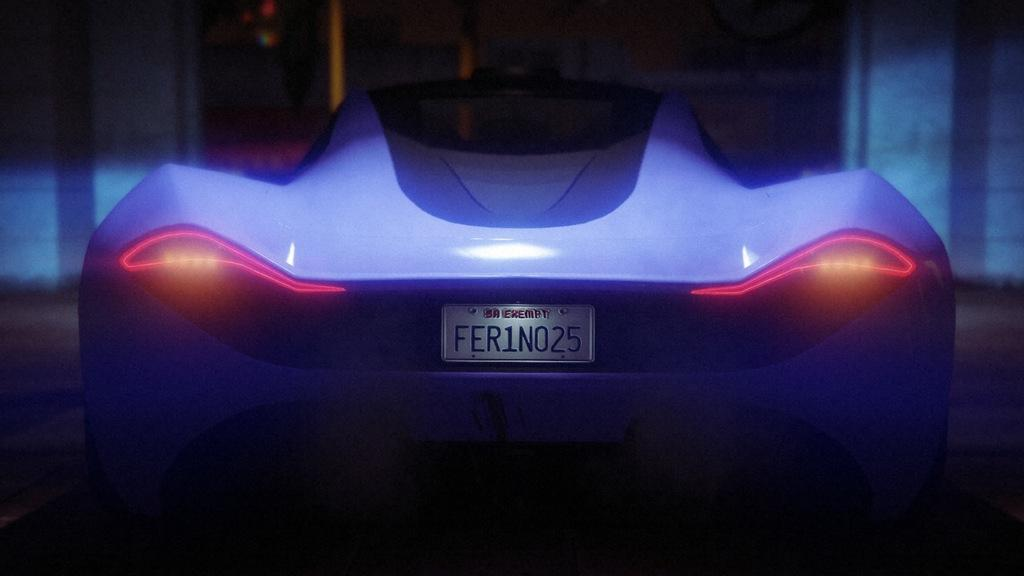What type of vehicle is in the image? There is a blue car in the image. Is there any text present in the image? Yes, there is text written on the car or somewhere in the image. How would you describe the lighting in the image? The image appears to be slightly dark. How much debt is the car in the image currently in? There is no information about the car's debt in the image, as it is not relevant to the image's content. 